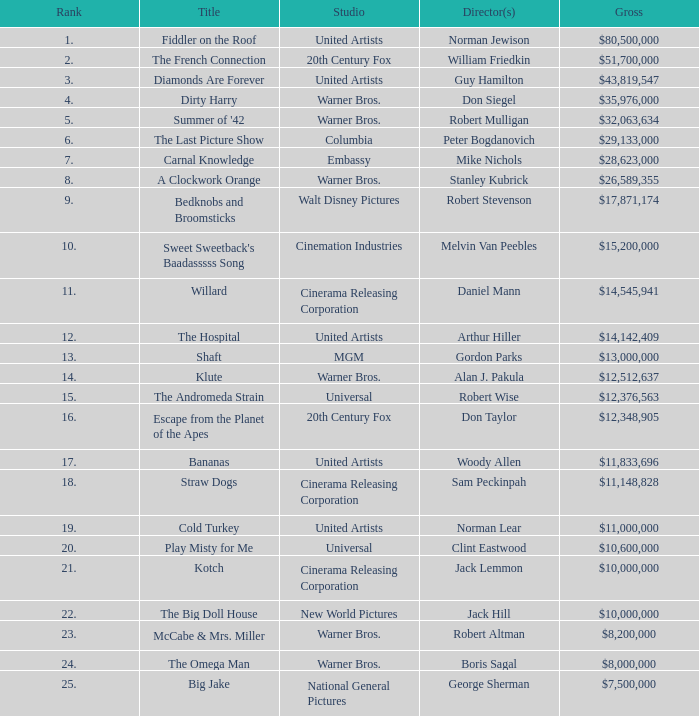What is the standing of the title with a gross income of $26,589,355? 8.0. 